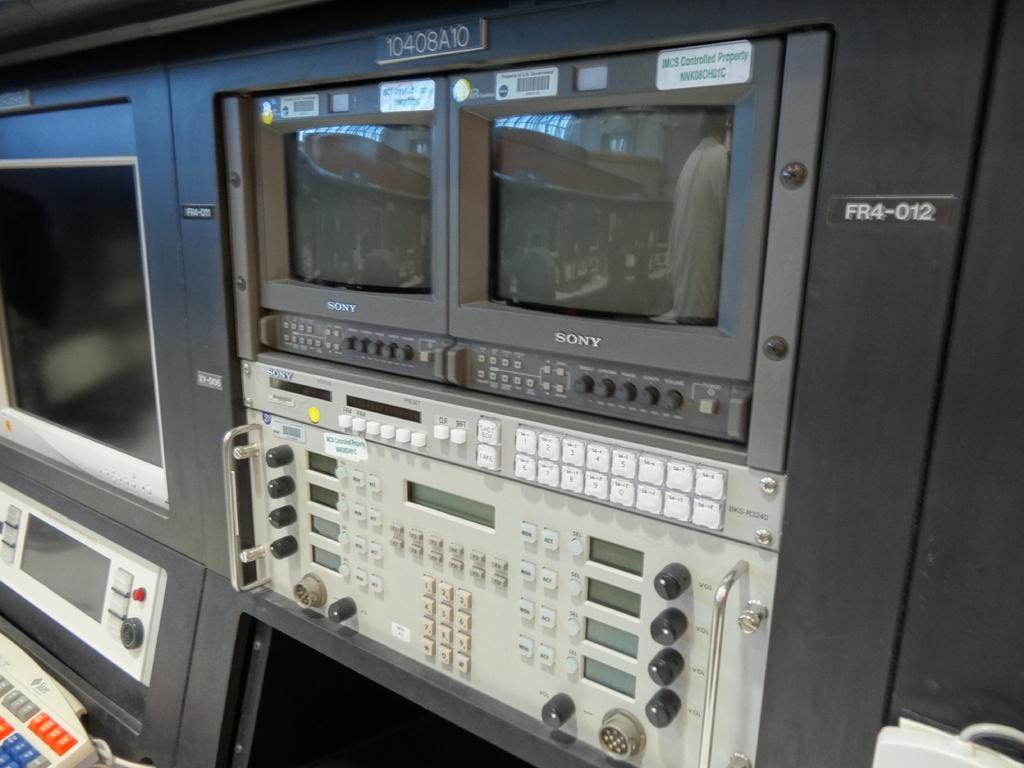<image>
Present a compact description of the photo's key features. Two Sony monitors are situated above a computer panel. 